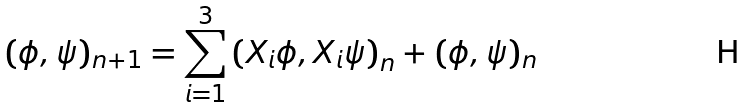<formula> <loc_0><loc_0><loc_500><loc_500>( \phi , \psi ) _ { n + 1 } = \sum _ { i = 1 } ^ { 3 } \left ( X _ { i } \phi , X _ { i } \psi \right ) _ { n } + ( \phi , \psi ) _ { n }</formula> 